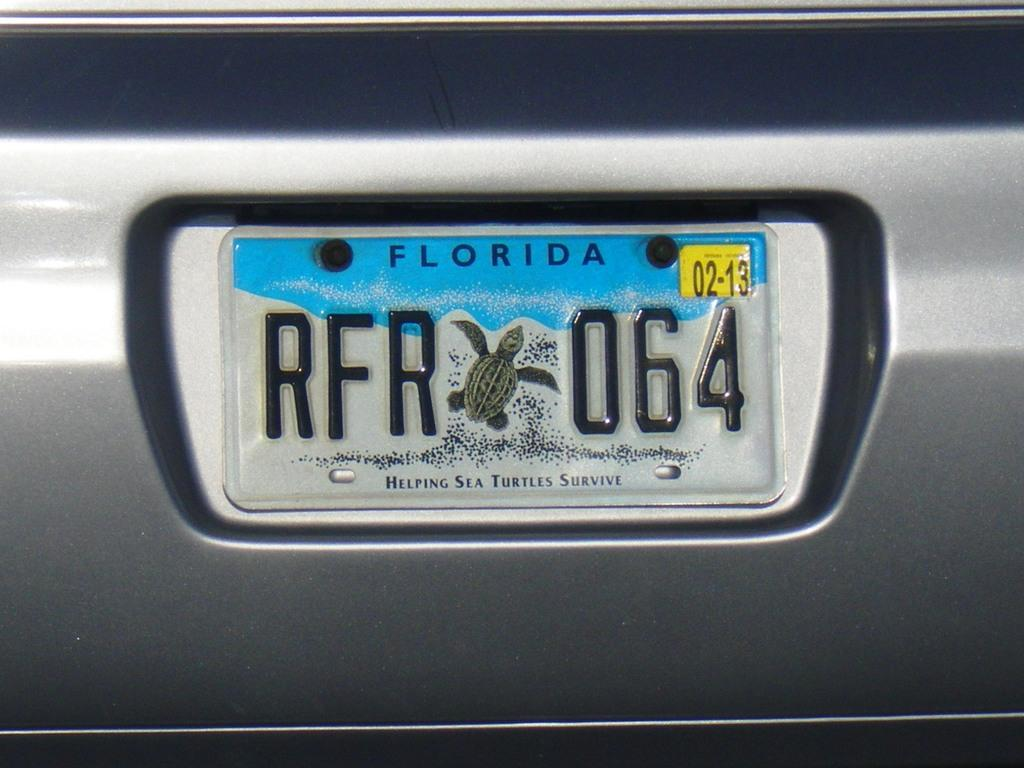Provide a one-sentence caption for the provided image. A close up image of a Florida license plate with the code RFR064. 